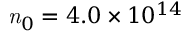<formula> <loc_0><loc_0><loc_500><loc_500>n _ { 0 } = 4 . 0 \times 1 0 ^ { 1 4 }</formula> 